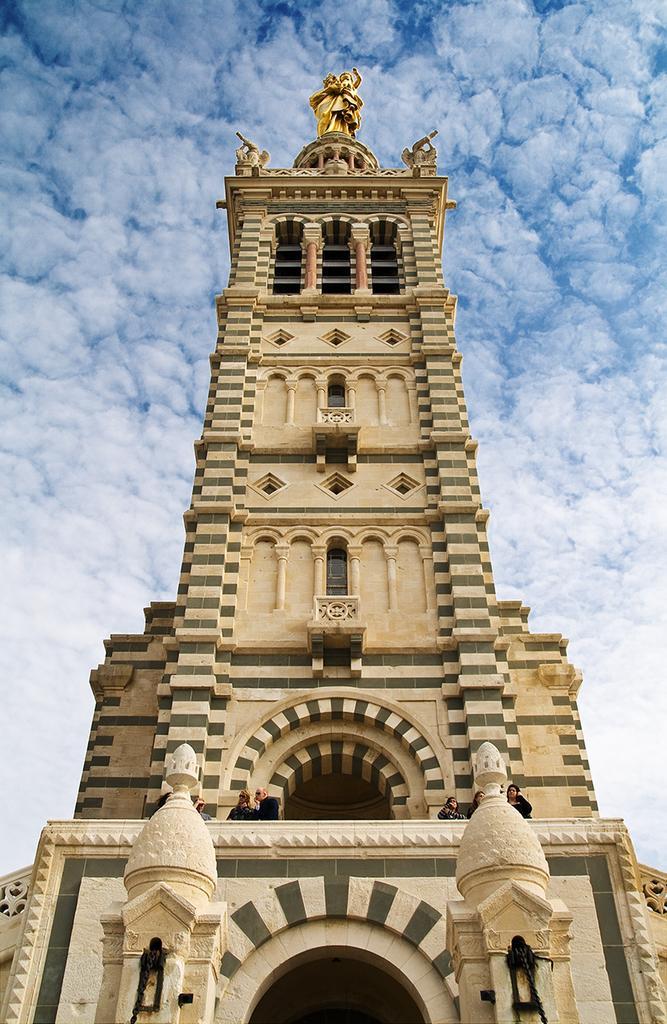Describe this image in one or two sentences. In the middle of the image there is a building, on the building there is a statue. Behind the building there are some clouds and sky. 